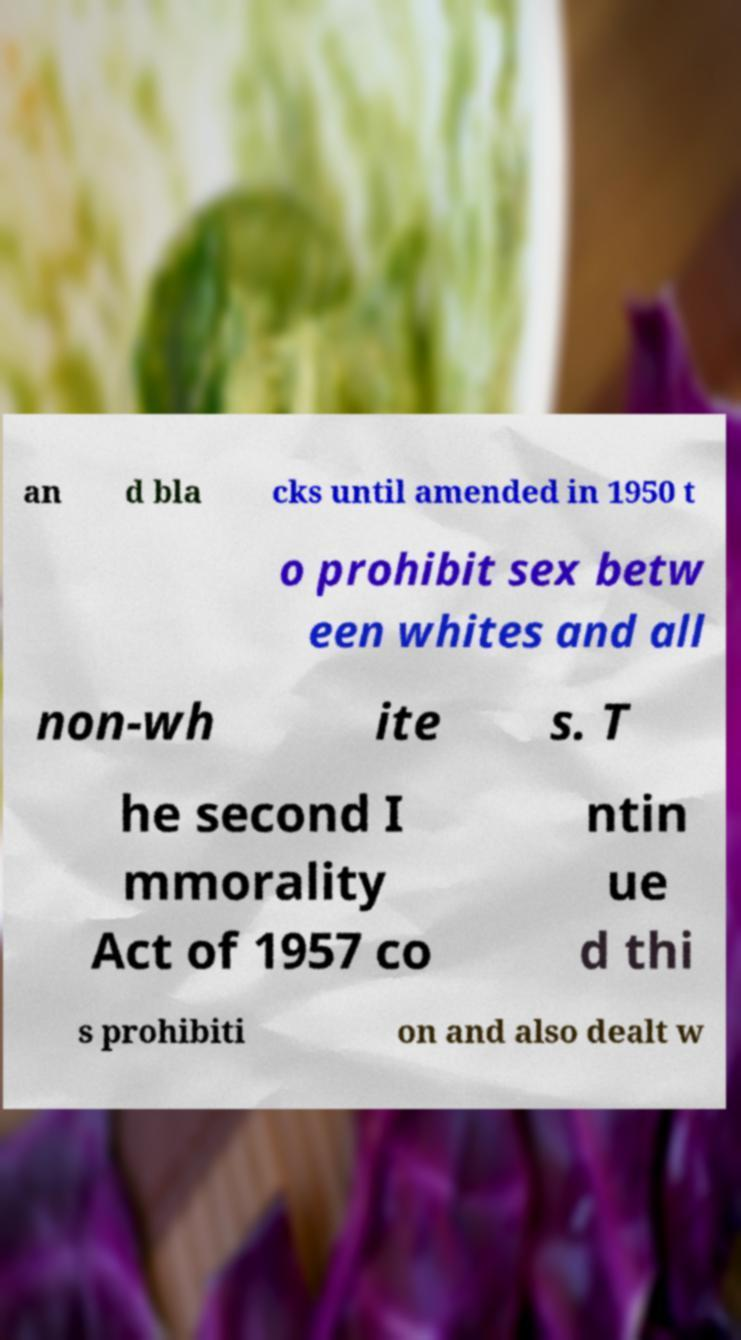Could you extract and type out the text from this image? an d bla cks until amended in 1950 t o prohibit sex betw een whites and all non-wh ite s. T he second I mmorality Act of 1957 co ntin ue d thi s prohibiti on and also dealt w 